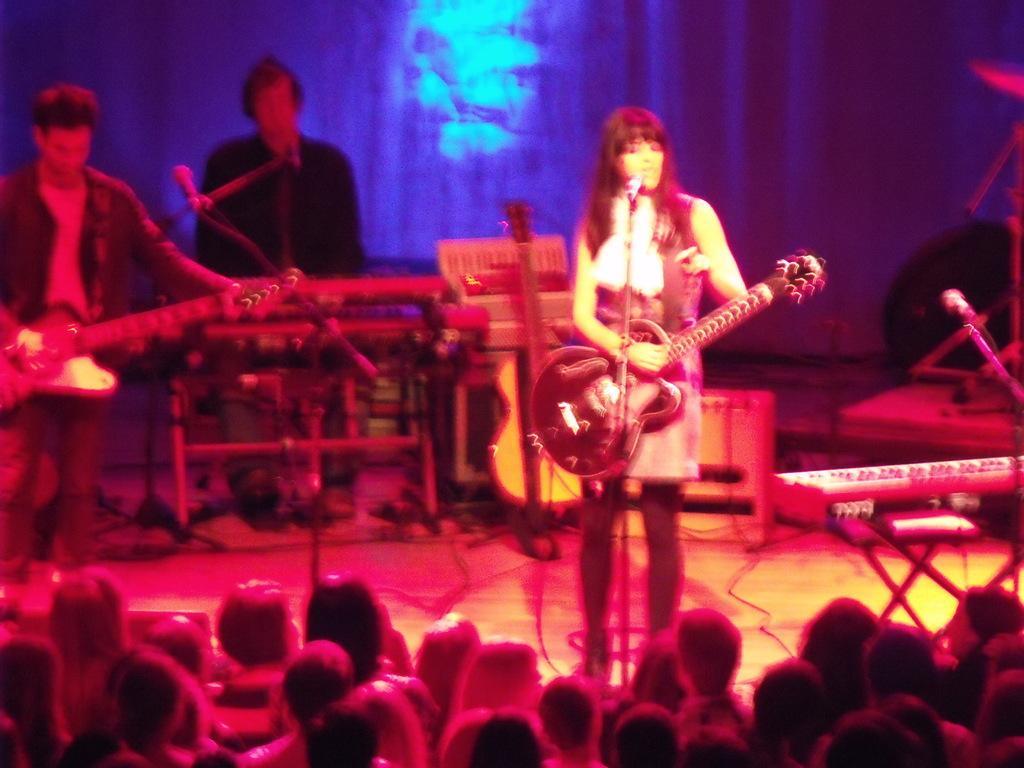Describe this image in one or two sentences. The picture in a musical concert where three people are on stage and a guy in the background is playing a piano and there are spectators viewing them from the floor. The background is blue in color. 